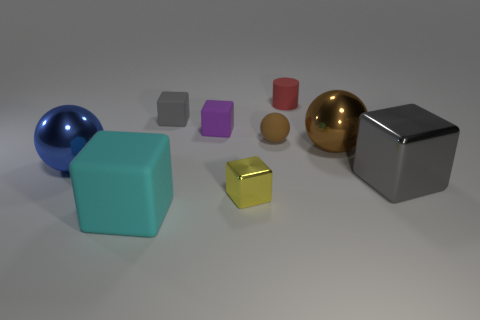Subtract all large gray blocks. How many blocks are left? 4 Subtract 2 blocks. How many blocks are left? 3 Subtract all brown spheres. How many spheres are left? 1 Subtract all spheres. How many objects are left? 6 Subtract all purple cylinders. How many green cubes are left? 0 Subtract 1 yellow blocks. How many objects are left? 8 Subtract all gray blocks. Subtract all brown balls. How many blocks are left? 3 Subtract all purple cubes. Subtract all tiny yellow matte things. How many objects are left? 8 Add 7 blue objects. How many blue objects are left? 8 Add 6 brown metal things. How many brown metal things exist? 7 